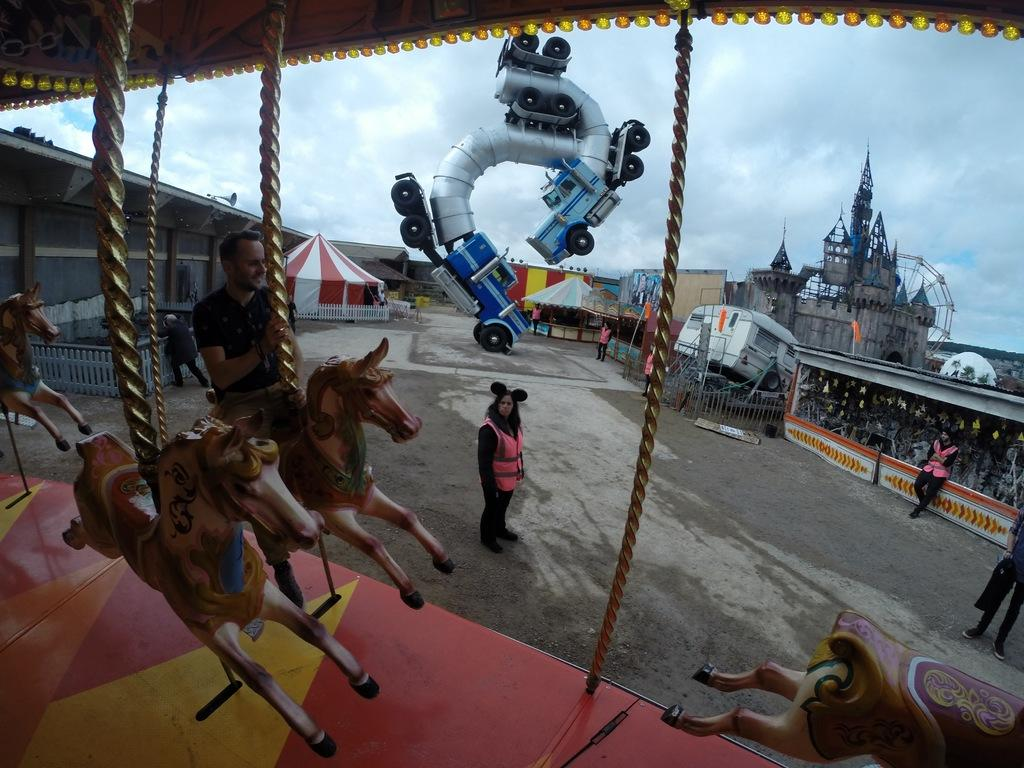What is the person on the left side of the image doing? The person is sitting on a toy horse on the left side of the image. What is the woman in the middle of the image doing? The woman is standing in the middle of the image. What can be seen in the background of the image? The background of the image is the sky. How many bears are visible in the image during the rainstorm? There are no bears or rainstorm present in the image; it features a person on a toy horse and a woman standing in front of a sky background. 